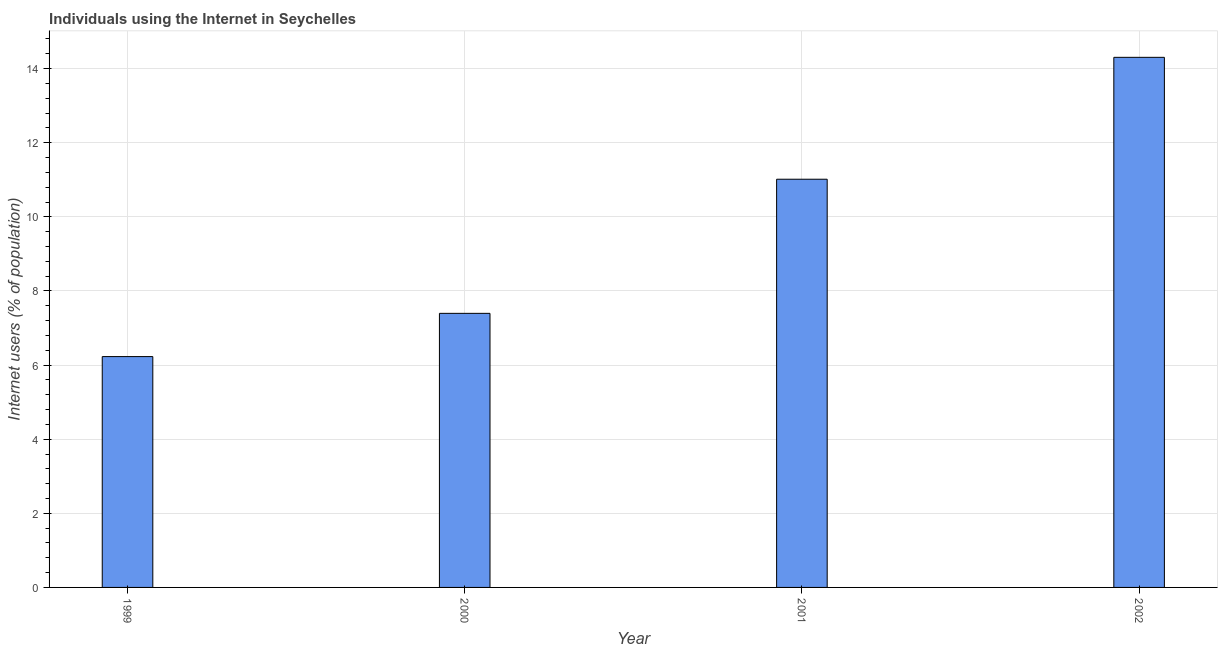Does the graph contain grids?
Your answer should be very brief. Yes. What is the title of the graph?
Offer a terse response. Individuals using the Internet in Seychelles. What is the label or title of the Y-axis?
Your response must be concise. Internet users (% of population). What is the number of internet users in 2000?
Give a very brief answer. 7.4. Across all years, what is the maximum number of internet users?
Ensure brevity in your answer.  14.3. Across all years, what is the minimum number of internet users?
Provide a short and direct response. 6.23. In which year was the number of internet users minimum?
Make the answer very short. 1999. What is the sum of the number of internet users?
Keep it short and to the point. 38.94. What is the difference between the number of internet users in 2000 and 2001?
Offer a very short reply. -3.62. What is the average number of internet users per year?
Your response must be concise. 9.74. What is the median number of internet users?
Provide a succinct answer. 9.21. In how many years, is the number of internet users greater than 4 %?
Make the answer very short. 4. What is the ratio of the number of internet users in 1999 to that in 2002?
Your answer should be compact. 0.43. What is the difference between the highest and the second highest number of internet users?
Your response must be concise. 3.29. Is the sum of the number of internet users in 1999 and 2002 greater than the maximum number of internet users across all years?
Your response must be concise. Yes. What is the difference between the highest and the lowest number of internet users?
Your answer should be very brief. 8.08. In how many years, is the number of internet users greater than the average number of internet users taken over all years?
Keep it short and to the point. 2. How many years are there in the graph?
Ensure brevity in your answer.  4. What is the difference between two consecutive major ticks on the Y-axis?
Your answer should be very brief. 2. What is the Internet users (% of population) in 1999?
Give a very brief answer. 6.23. What is the Internet users (% of population) of 2000?
Your answer should be compact. 7.4. What is the Internet users (% of population) in 2001?
Ensure brevity in your answer.  11.02. What is the Internet users (% of population) of 2002?
Give a very brief answer. 14.3. What is the difference between the Internet users (% of population) in 1999 and 2000?
Keep it short and to the point. -1.17. What is the difference between the Internet users (% of population) in 1999 and 2001?
Provide a short and direct response. -4.79. What is the difference between the Internet users (% of population) in 1999 and 2002?
Offer a terse response. -8.08. What is the difference between the Internet users (% of population) in 2000 and 2001?
Give a very brief answer. -3.62. What is the difference between the Internet users (% of population) in 2000 and 2002?
Your answer should be very brief. -6.91. What is the difference between the Internet users (% of population) in 2001 and 2002?
Your response must be concise. -3.29. What is the ratio of the Internet users (% of population) in 1999 to that in 2000?
Provide a short and direct response. 0.84. What is the ratio of the Internet users (% of population) in 1999 to that in 2001?
Give a very brief answer. 0.57. What is the ratio of the Internet users (% of population) in 1999 to that in 2002?
Keep it short and to the point. 0.43. What is the ratio of the Internet users (% of population) in 2000 to that in 2001?
Provide a succinct answer. 0.67. What is the ratio of the Internet users (% of population) in 2000 to that in 2002?
Keep it short and to the point. 0.52. What is the ratio of the Internet users (% of population) in 2001 to that in 2002?
Your answer should be compact. 0.77. 